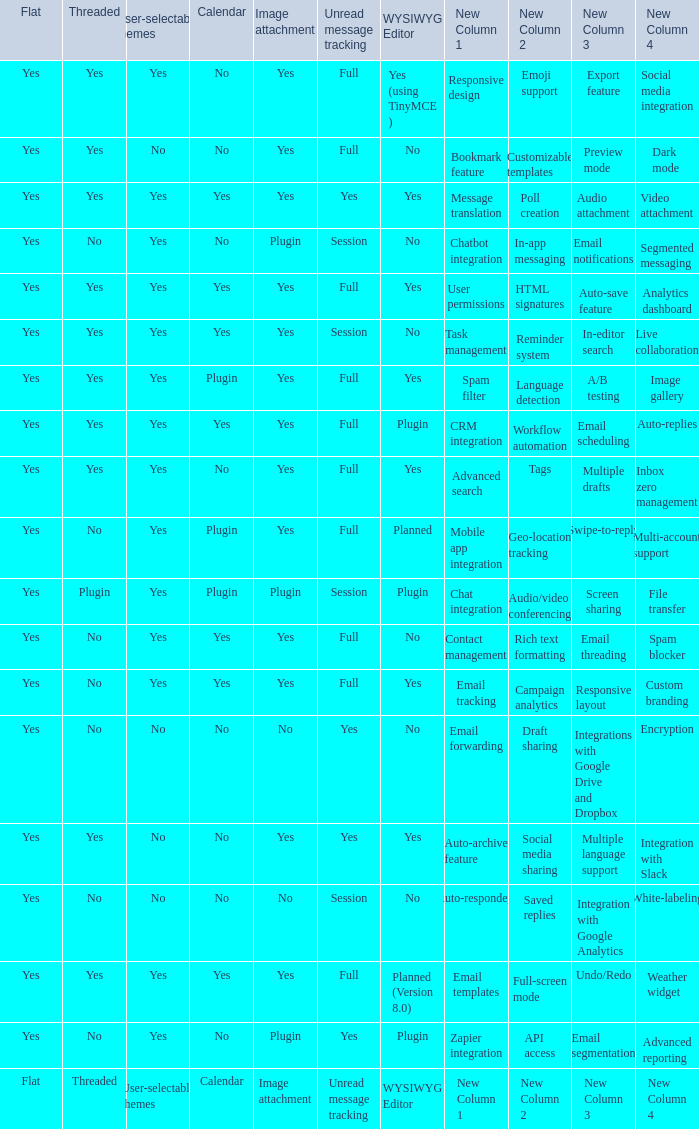Which Image attachment has a Threaded of yes, and a Calendar of yes? Yes, Yes, Yes, Yes, Yes. Could you help me parse every detail presented in this table? {'header': ['Flat', 'Threaded', 'User-selectable themes', 'Calendar', 'Image attachment', 'Unread message tracking', 'WYSIWYG Editor', 'New Column 1', 'New Column 2', 'New Column 3', 'New Column 4'], 'rows': [['Yes', 'Yes', 'Yes', 'No', 'Yes', 'Full', 'Yes (using TinyMCE )', 'Responsive design', 'Emoji support', 'Export feature', 'Social media integration'], ['Yes', 'Yes', 'No', 'No', 'Yes', 'Full', 'No', 'Bookmark feature', 'Customizable templates', 'Preview mode', 'Dark mode '], ['Yes', 'Yes', 'Yes', 'Yes', 'Yes', 'Yes', 'Yes', 'Message translation', 'Poll creation', 'Audio attachment', 'Video attachment '], ['Yes', 'No', 'Yes', 'No', 'Plugin', 'Session', 'No', 'Chatbot integration', 'In-app messaging', 'Email notifications', 'Segmented messaging'], ['Yes', 'Yes', 'Yes', 'Yes', 'Yes', 'Full', 'Yes', 'User permissions', 'HTML signatures', 'Auto-save feature', 'Analytics dashboard'], ['Yes', 'Yes', 'Yes', 'Yes', 'Yes', 'Session', 'No', 'Task management', 'Reminder system', 'In-editor search', 'Live collaboration'], ['Yes', 'Yes', 'Yes', 'Plugin', 'Yes', 'Full', 'Yes', 'Spam filter', 'Language detection', 'A/B testing', 'Image gallery'], ['Yes', 'Yes', 'Yes', 'Yes', 'Yes', 'Full', 'Plugin', 'CRM integration', 'Workflow automation', 'Email scheduling', 'Auto-replies'], ['Yes', 'Yes', 'Yes', 'No', 'Yes', 'Full', 'Yes', 'Advanced search', 'Tags', 'Multiple drafts', 'Inbox zero management'], ['Yes', 'No', 'Yes', 'Plugin', 'Yes', 'Full', 'Planned', 'Mobile app integration', 'Geo-location tracking', 'Swipe-to-reply', 'Multi-account support '], ['Yes', 'Plugin', 'Yes', 'Plugin', 'Plugin', 'Session', 'Plugin', 'Chat integration', 'Audio/video conferencing', 'Screen sharing', 'File transfer'], ['Yes', 'No', 'Yes', 'Yes', 'Yes', 'Full', 'No', 'Contact management', 'Rich text formatting', 'Email threading', 'Spam blocker'], ['Yes', 'No', 'Yes', 'Yes', 'Yes', 'Full', 'Yes', 'Email tracking', 'Campaign analytics', 'Responsive layout', 'Custom branding'], ['Yes', 'No', 'No', 'No', 'No', 'Yes', 'No', 'Email forwarding', 'Draft sharing', 'Integrations with Google Drive and Dropbox', 'Encryption'], ['Yes', 'Yes', 'No', 'No', 'Yes', 'Yes', 'Yes', 'Auto-archive feature', 'Social media sharing', 'Multiple language support', 'Integration with Slack'], ['Yes', 'No', 'No', 'No', 'No', 'Session', 'No', 'Auto-responders', 'Saved replies', 'Integration with Google Analytics', 'White-labeling'], ['Yes', 'Yes', 'Yes', 'Yes', 'Yes', 'Full', 'Planned (Version 8.0)', 'Email templates', 'Full-screen mode', 'Undo/Redo', 'Weather widget'], ['Yes', 'No', 'Yes', 'No', 'Plugin', 'Yes', 'Plugin', 'Zapier integration', 'API access', 'Email segmentation', 'Advanced reporting '], ['Flat', 'Threaded', 'User-selectable themes', 'Calendar', 'Image attachment', 'Unread message tracking', 'WYSIWYG Editor', 'New Column 1', 'New Column 2', 'New Column 3', 'New Column 4']]} 